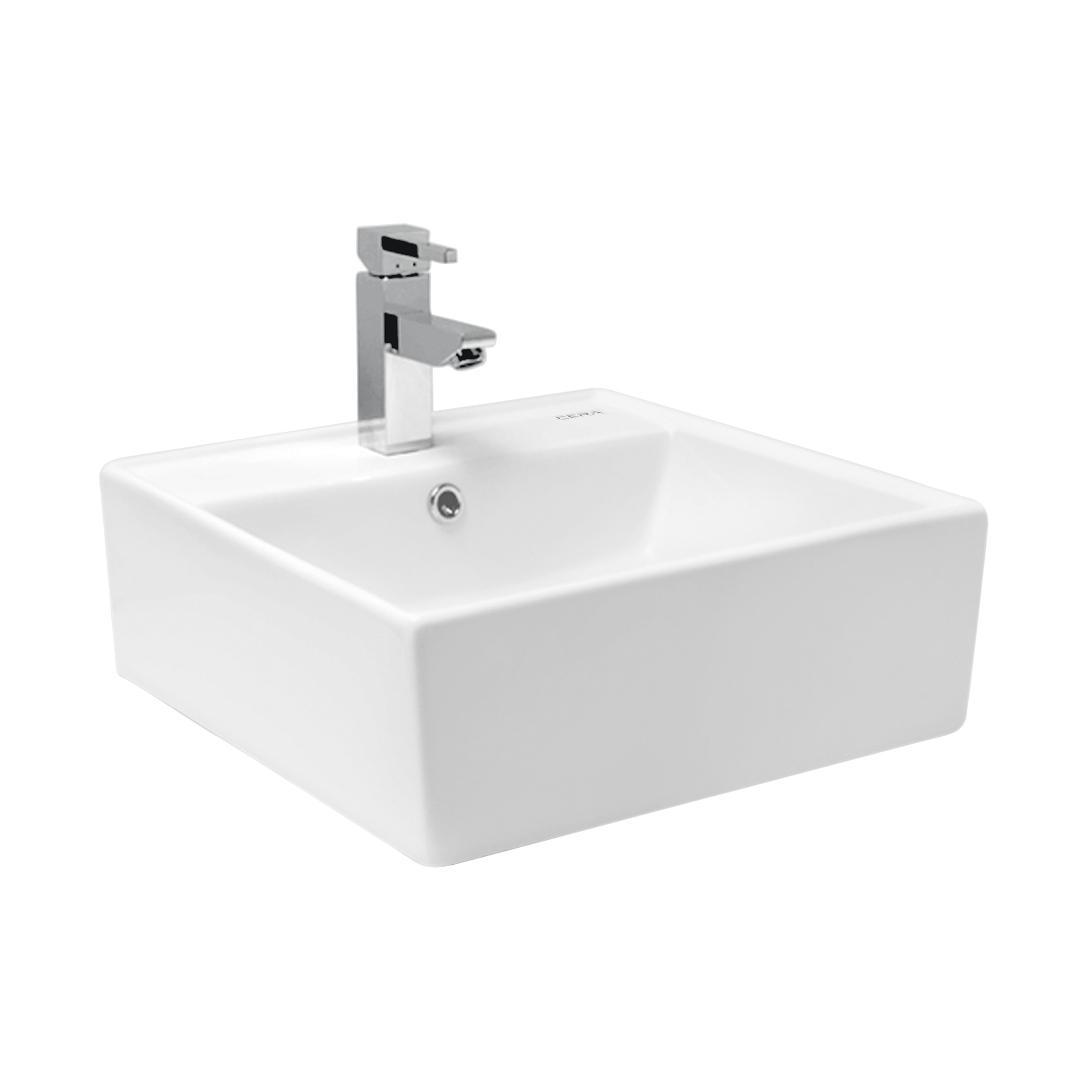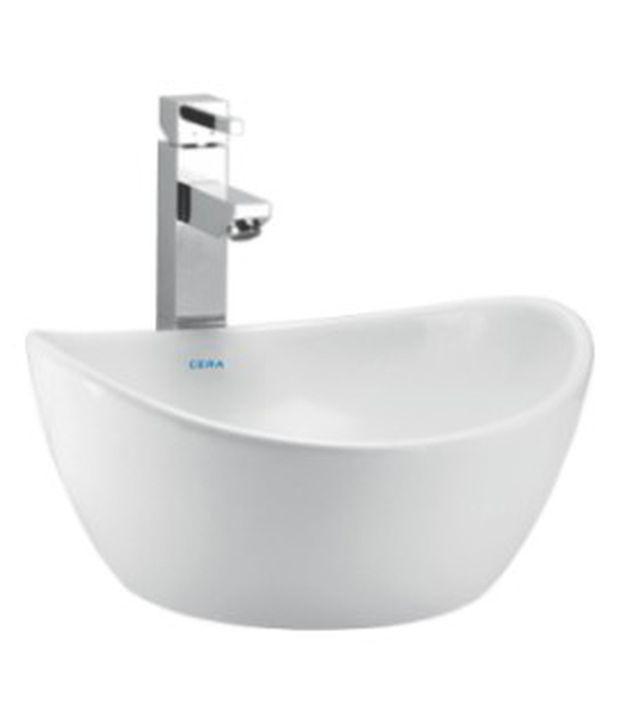The first image is the image on the left, the second image is the image on the right. Considering the images on both sides, is "Each sink has a rounded outer edge and back edge that fits parallel to a wall." valid? Answer yes or no. No. The first image is the image on the left, the second image is the image on the right. Considering the images on both sides, is "There is a square sink in one of the images." valid? Answer yes or no. Yes. 